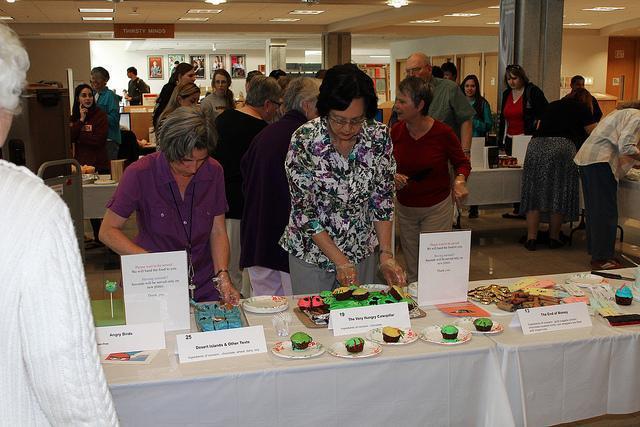How many people can be seen?
Give a very brief answer. 8. 